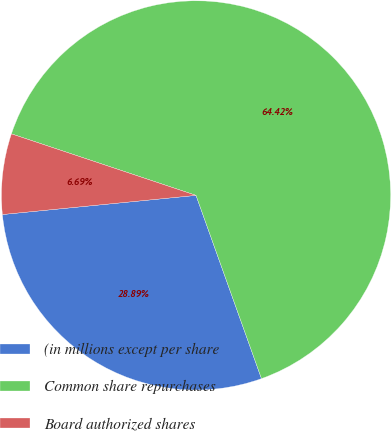Convert chart to OTSL. <chart><loc_0><loc_0><loc_500><loc_500><pie_chart><fcel>(in millions except per share<fcel>Common share repurchases<fcel>Board authorized shares<nl><fcel>28.89%<fcel>64.42%<fcel>6.69%<nl></chart> 